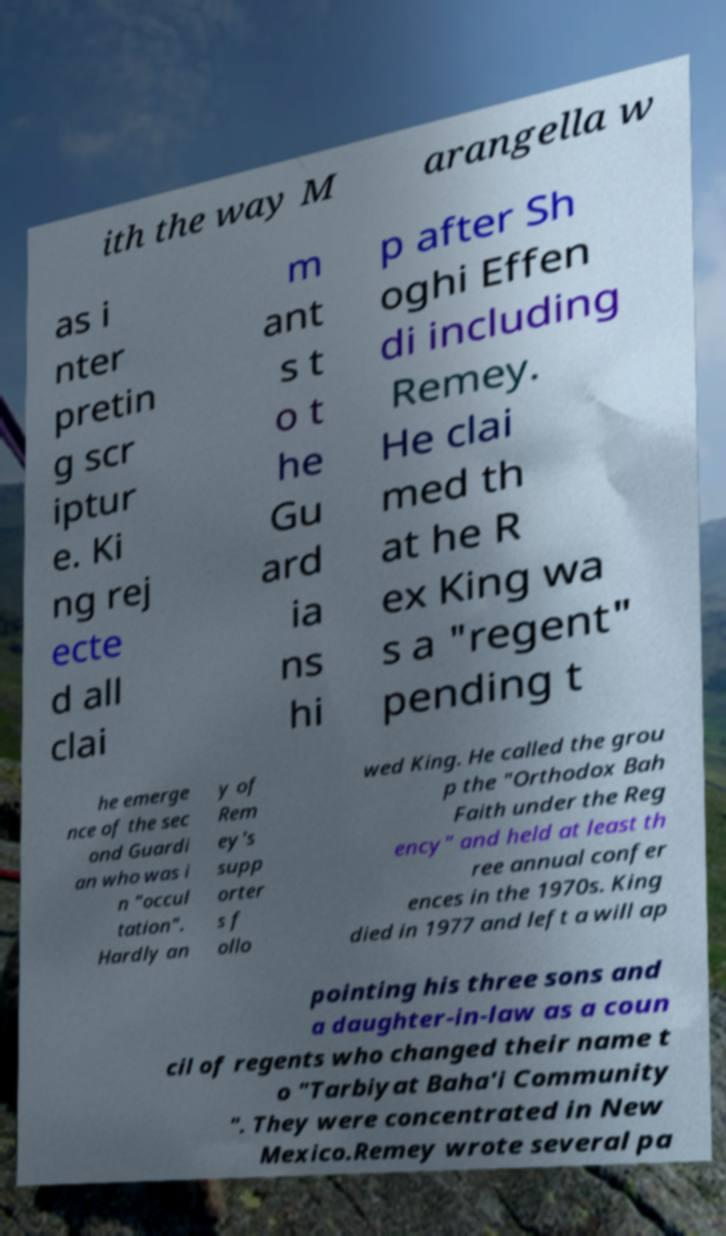Please read and relay the text visible in this image. What does it say? ith the way M arangella w as i nter pretin g scr iptur e. Ki ng rej ecte d all clai m ant s t o t he Gu ard ia ns hi p after Sh oghi Effen di including Remey. He clai med th at he R ex King wa s a "regent" pending t he emerge nce of the sec ond Guardi an who was i n "occul tation". Hardly an y of Rem ey's supp orter s f ollo wed King. He called the grou p the "Orthodox Bah Faith under the Reg ency" and held at least th ree annual confer ences in the 1970s. King died in 1977 and left a will ap pointing his three sons and a daughter-in-law as a coun cil of regents who changed their name t o "Tarbiyat Baha'i Community ". They were concentrated in New Mexico.Remey wrote several pa 